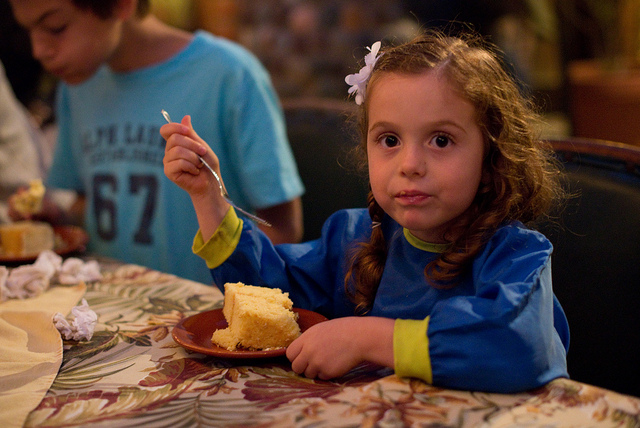Identify and read out the text in this image. 6 7 